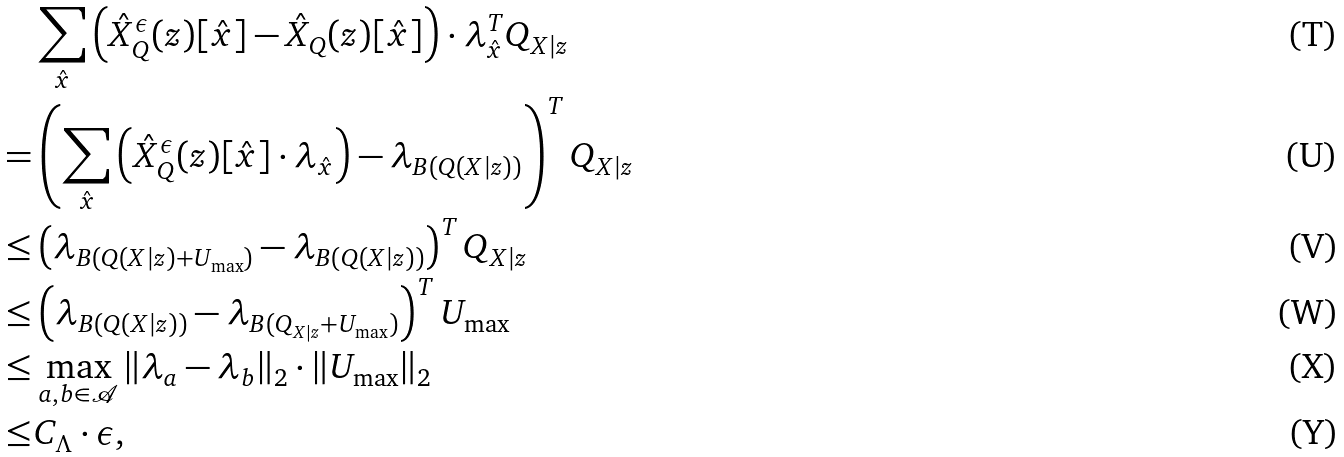<formula> <loc_0><loc_0><loc_500><loc_500>& \sum _ { \hat { x } } \left ( \hat { X } _ { Q } ^ { \epsilon } ( z ) [ \hat { x } ] - \hat { X } _ { Q } ( z ) [ \hat { x } ] \right ) \cdot \lambda _ { \hat { x } } ^ { T } Q _ { X | z } \\ = & \left ( \sum _ { \hat { x } } \left ( \hat { X } _ { Q } ^ { \epsilon } ( z ) [ \hat { x } ] \cdot \lambda _ { \hat { x } } \right ) - \lambda _ { B ( Q ( X | z ) ) } \right ) ^ { T } Q _ { X | z } \\ \leq & \left ( \lambda _ { B ( Q ( X | z ) + U _ { \max } ) } - \lambda _ { B ( Q ( X | z ) ) } \right ) ^ { T } Q _ { X | z } \\ \leq & \left ( \lambda _ { B ( Q ( X | z ) ) } - \lambda _ { B ( Q _ { X | z } + U _ { \max } ) } \right ) ^ { T } U _ { \max } \\ \leq & \max _ { a , b \in \mathcal { A } } \| \lambda _ { a } - \lambda _ { b } \| _ { 2 } \cdot \| U _ { \max } \| _ { 2 } \\ \leq & C _ { \Lambda } \cdot \epsilon ,</formula> 